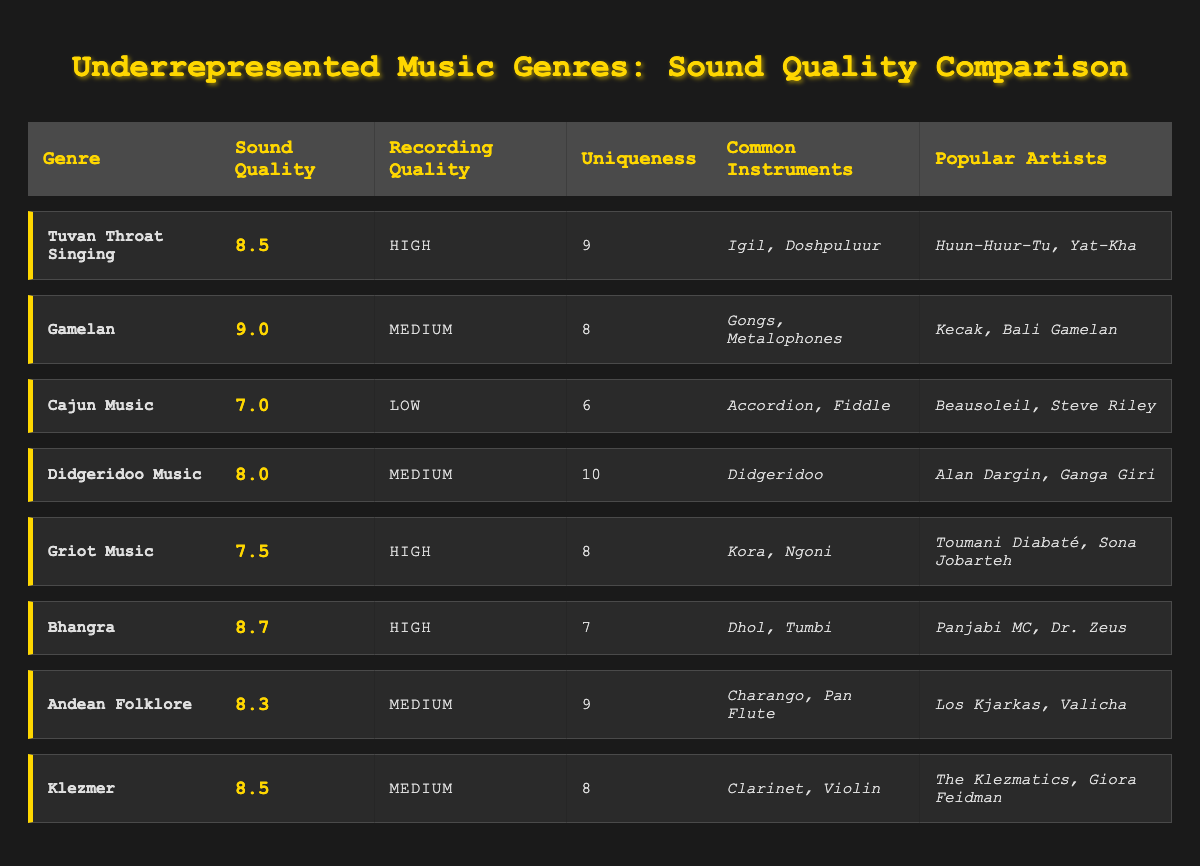What is the sound quality rating for Gamelan? According to the table, the sound quality rating for Gamelan is listed directly as 9.0
Answer: 9.0 Which genre has the highest uniqueness score? By scanning the uniqueness scores in the table, Didgeridoo Music has the highest score of 10.
Answer: Didgeridoo Music What is the recording quality of Cajun Music? The table indicates that the recording quality of Cajun Music is classified as Low.
Answer: Low What are the common instruments used in Tuvan Throat Singing? The table lists the common instruments for Tuvan Throat Singing as Igil and Doshpuluur.
Answer: Igil, Doshpuluur Which genres have a high recording quality? The table shows that Tuvan Throat Singing, Griot Music, and Bhangra all have a high recording quality listed.
Answer: Tuvan Throat Singing, Griot Music, Bhangra What is the average sound quality rating for all genres? Adding the sound quality ratings: (8.5 + 9.0 + 7.0 + 8.0 + 7.5 + 8.7 + 8.3 + 8.5) = 66.5 and dividing by 8 gives an average of 66.5/8 = 8.3125.
Answer: 8.31 Is it true that Bhangra has a higher sound quality rating than Griot Music? The table indicates Bhangra's rating is 8.7 while Griot Music's is 7.5, confirming that Bhangra has a higher rating.
Answer: True Which genre has a sound quality rating closest to 8.0? The genres with sound quality ratings closest to 8.0 are Didgeridoo Music (8.0) and Cajun Music (7.0). The closest is Didgeridoo Music.
Answer: Didgeridoo Music What is the difference in uniqueness scores between Gamelan and Cajun Music? The uniqueness score for Gamelan is 8 and for Cajun Music, it is 6. The difference is calculated as 8 - 6 = 2.
Answer: 2 List the popular artists of Andean Folklore. The table states that the popular artists for Andean Folklore are Los Kjarkas and Valicha.
Answer: Los Kjarkas, Valicha 